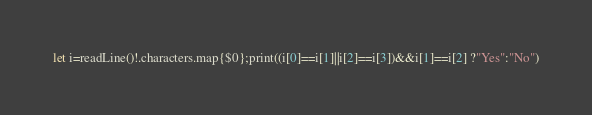<code> <loc_0><loc_0><loc_500><loc_500><_Swift_>let i=readLine()!.characters.map{$0};print((i[0]==i[1]||i[2]==i[3])&&i[1]==i[2] ?"Yes":"No")</code> 